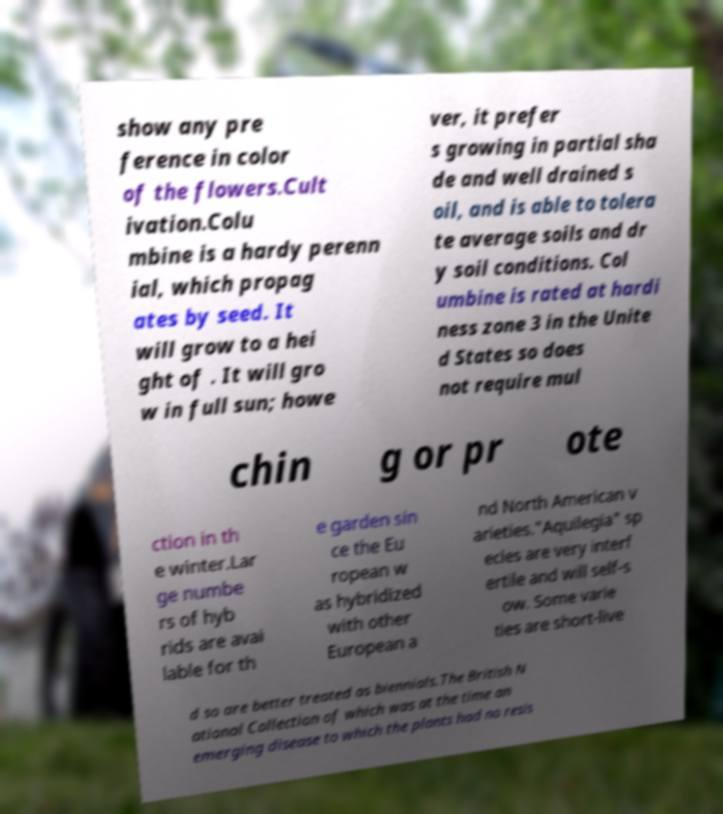Please identify and transcribe the text found in this image. show any pre ference in color of the flowers.Cult ivation.Colu mbine is a hardy perenn ial, which propag ates by seed. It will grow to a hei ght of . It will gro w in full sun; howe ver, it prefer s growing in partial sha de and well drained s oil, and is able to tolera te average soils and dr y soil conditions. Col umbine is rated at hardi ness zone 3 in the Unite d States so does not require mul chin g or pr ote ction in th e winter.Lar ge numbe rs of hyb rids are avai lable for th e garden sin ce the Eu ropean w as hybridized with other European a nd North American v arieties."Aquilegia" sp ecies are very interf ertile and will self-s ow. Some varie ties are short-live d so are better treated as biennials.The British N ational Collection of which was at the time an emerging disease to which the plants had no resis 